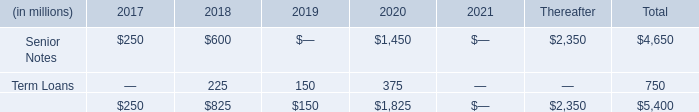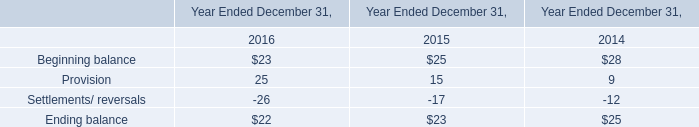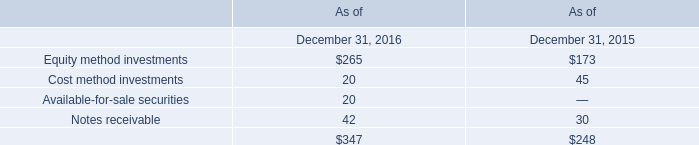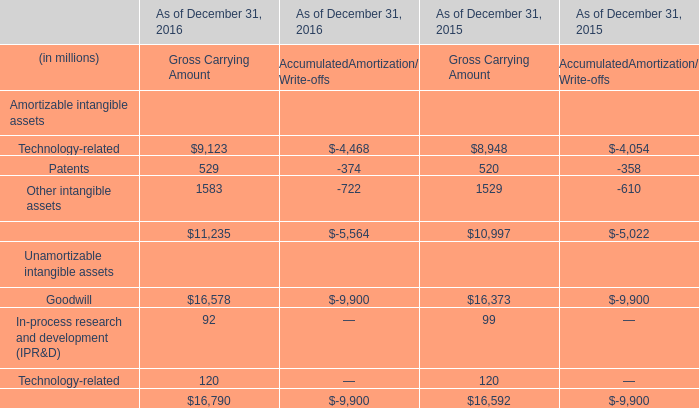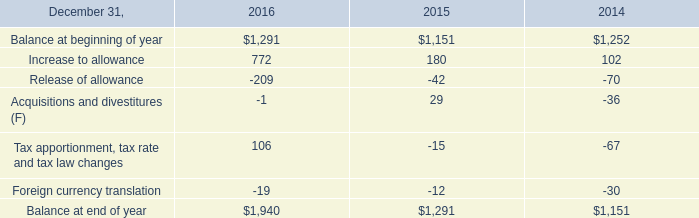In what year is Gross Carrying Amount for Goodwill greater than 16500? 
Answer: 2016. 